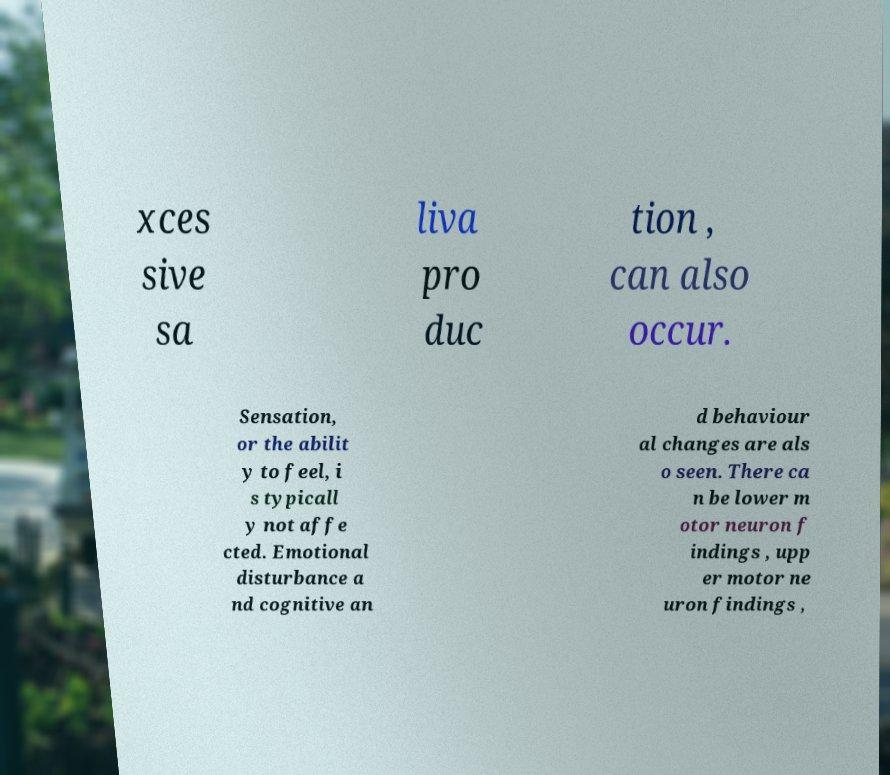Can you read and provide the text displayed in the image?This photo seems to have some interesting text. Can you extract and type it out for me? xces sive sa liva pro duc tion , can also occur. Sensation, or the abilit y to feel, i s typicall y not affe cted. Emotional disturbance a nd cognitive an d behaviour al changes are als o seen. There ca n be lower m otor neuron f indings , upp er motor ne uron findings , 